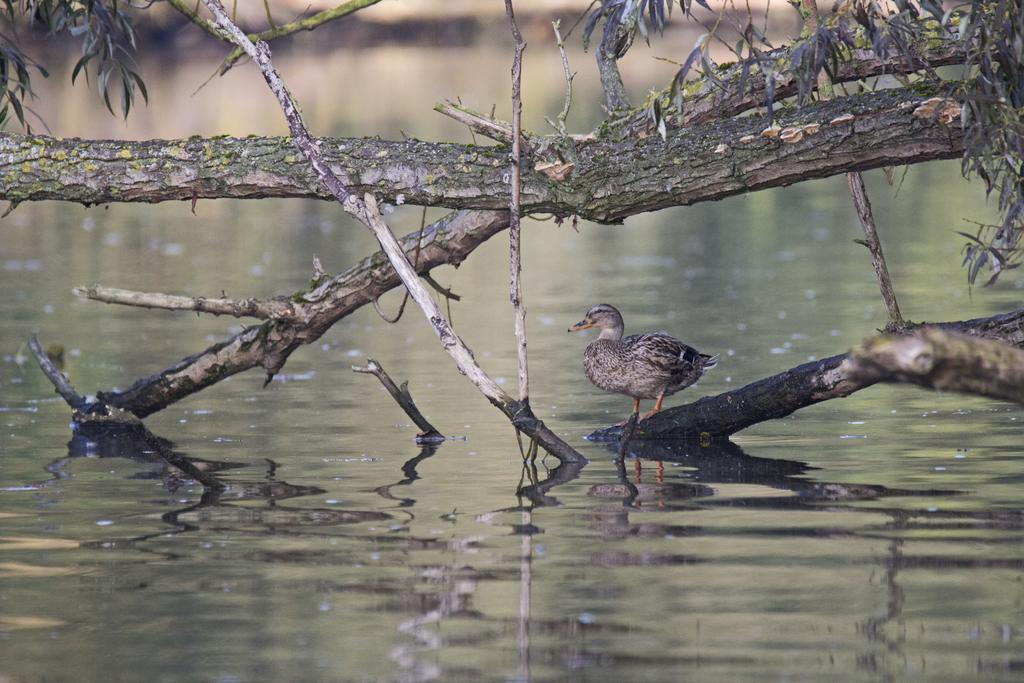What natural elements are present in the image? There is a tree branch and leaves in the image. What type of animal can be seen in the image? There is a bird in the image. What is the water in the image used for? The water is visible in the image, but its purpose is not specified. What color is the cub's sweater in the image? There is no cub or sweater present in the image. How much sand can be seen in the image? There is no sand present in the image. 